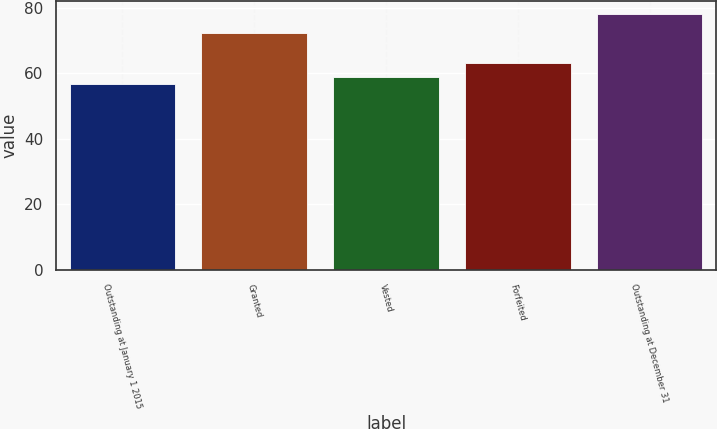<chart> <loc_0><loc_0><loc_500><loc_500><bar_chart><fcel>Outstanding at January 1 2015<fcel>Granted<fcel>Vested<fcel>Forfeited<fcel>Outstanding at December 31<nl><fcel>56.84<fcel>72.24<fcel>58.98<fcel>63.1<fcel>78.28<nl></chart> 